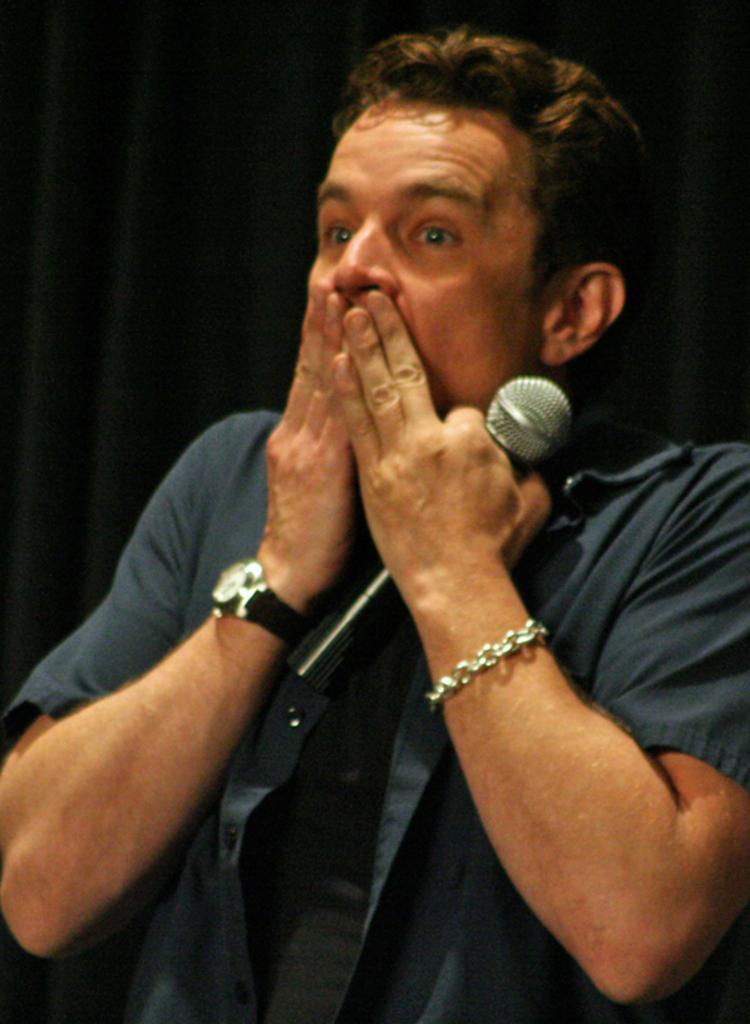Describe this image in one or two sentences. In this picture there is a man wearing a blue shirt is holding a mic in his hand. He is wearing a bracelet and a black watch in his hands. There is a black curtain at the background. 